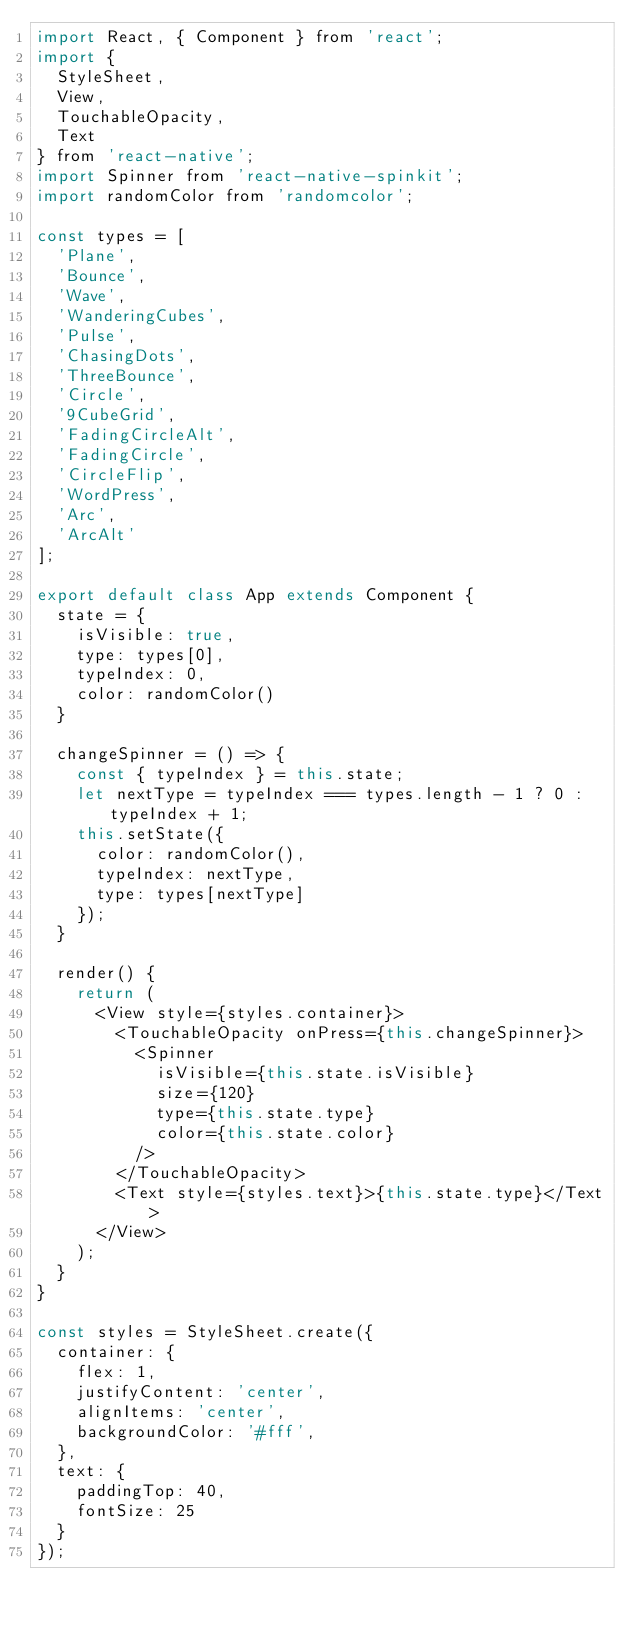<code> <loc_0><loc_0><loc_500><loc_500><_JavaScript_>import React, { Component } from 'react';
import {
  StyleSheet,
  View,
  TouchableOpacity,
  Text
} from 'react-native';
import Spinner from 'react-native-spinkit';
import randomColor from 'randomcolor';

const types = [
  'Plane',
  'Bounce',
  'Wave',
  'WanderingCubes',
  'Pulse',
  'ChasingDots',
  'ThreeBounce',
  'Circle',
  '9CubeGrid',
  'FadingCircleAlt',
  'FadingCircle',
  'CircleFlip',
  'WordPress',
  'Arc',
  'ArcAlt'
];

export default class App extends Component {
  state = {
    isVisible: true,
    type: types[0],
    typeIndex: 0,
    color: randomColor()
  }

  changeSpinner = () => {
    const { typeIndex } = this.state;
    let nextType = typeIndex === types.length - 1 ? 0 : typeIndex + 1;
    this.setState({
      color: randomColor(),
      typeIndex: nextType,
      type: types[nextType]
    });
  }

  render() {
    return (
      <View style={styles.container}>
        <TouchableOpacity onPress={this.changeSpinner}>
          <Spinner
            isVisible={this.state.isVisible}
            size={120}
            type={this.state.type}
            color={this.state.color}
          />
        </TouchableOpacity>
        <Text style={styles.text}>{this.state.type}</Text>
      </View>
    );
  }
}

const styles = StyleSheet.create({
  container: {
    flex: 1,
    justifyContent: 'center',
    alignItems: 'center',
    backgroundColor: '#fff',
  },
  text: {
    paddingTop: 40,
    fontSize: 25
  }
});
</code> 